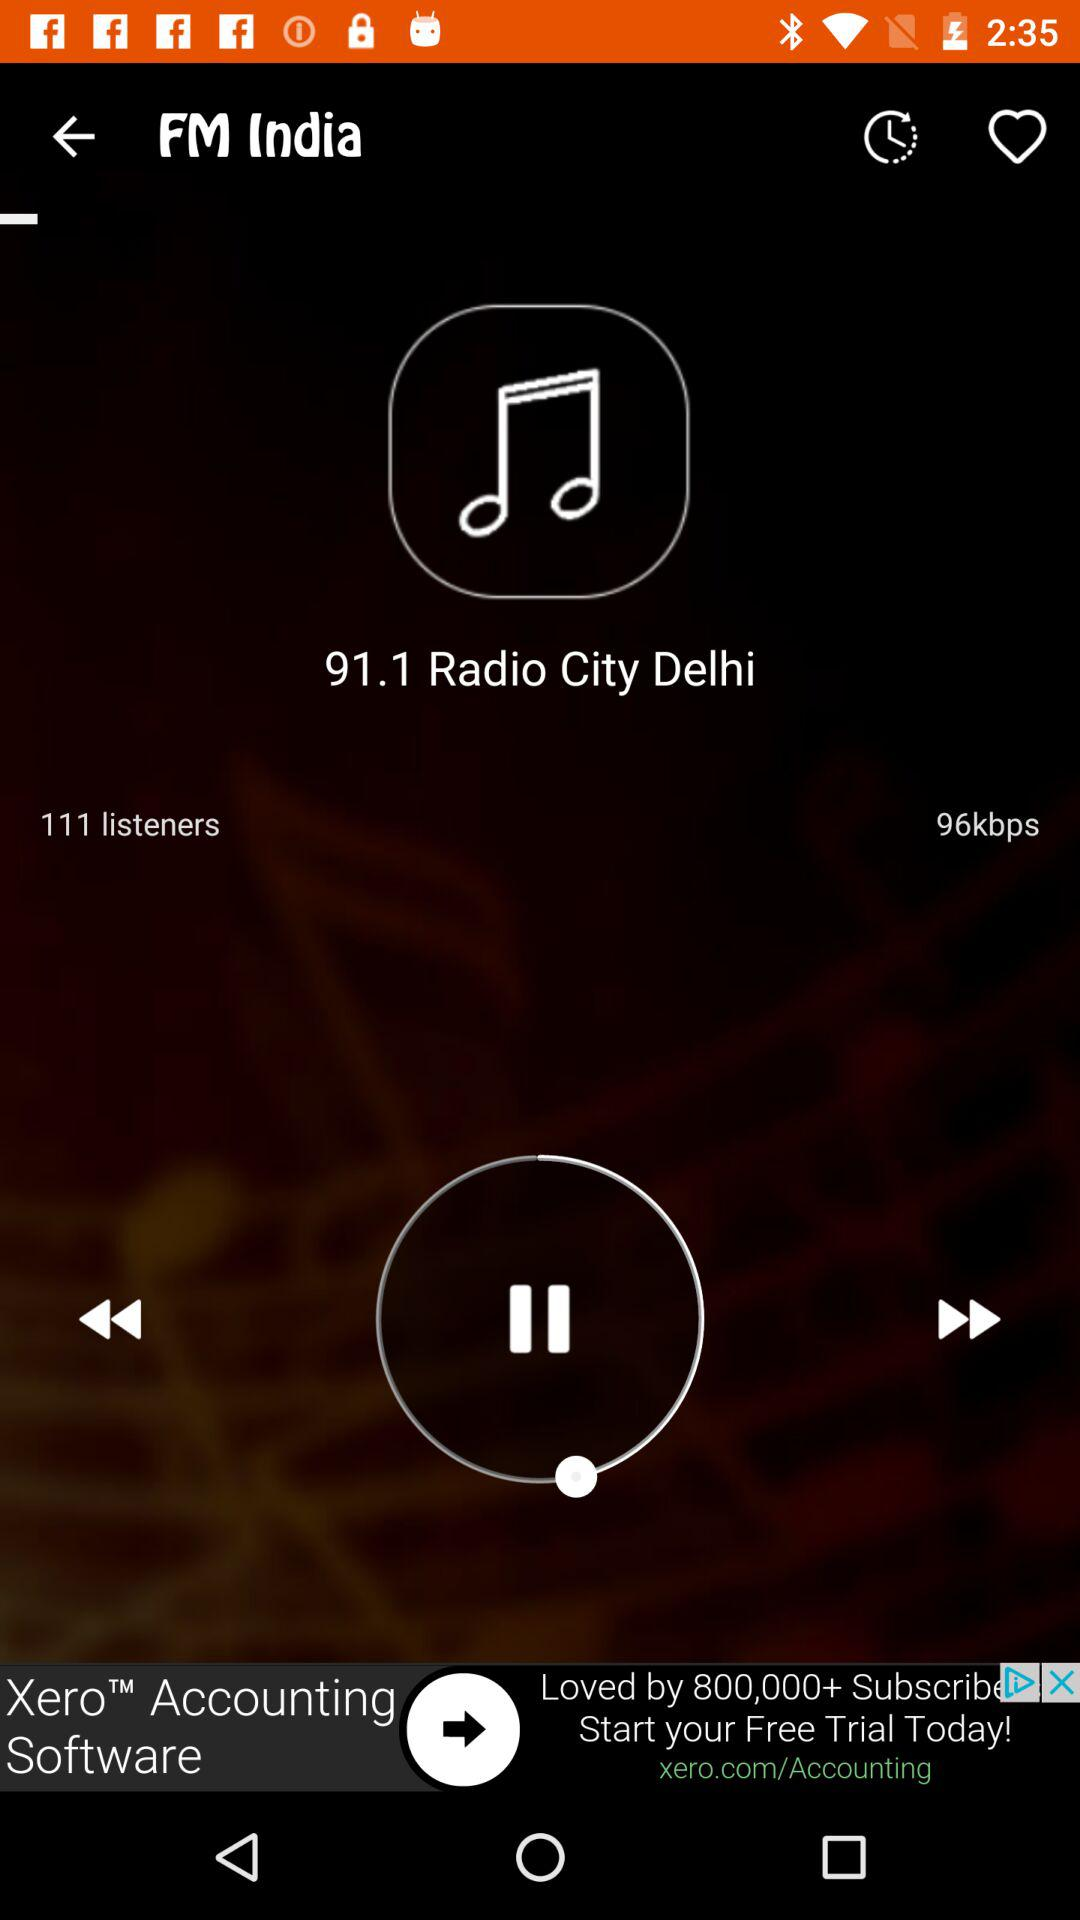What FM station is now broadcasting? The FM station now broadcasting is 91.1. 